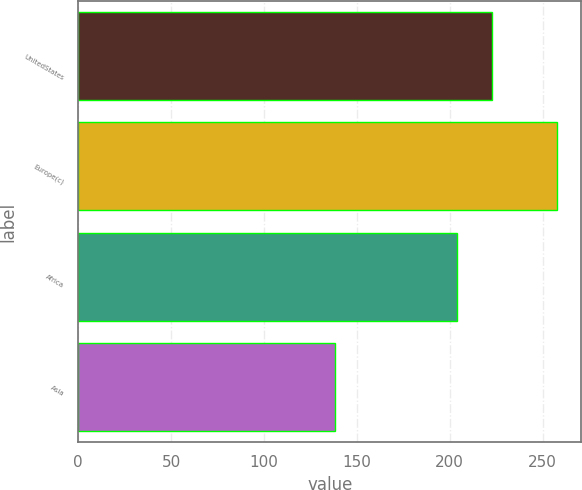Convert chart to OTSL. <chart><loc_0><loc_0><loc_500><loc_500><bar_chart><fcel>UnitedStates<fcel>Europe(c)<fcel>Africa<fcel>Asia<nl><fcel>223<fcel>258<fcel>204<fcel>138<nl></chart> 